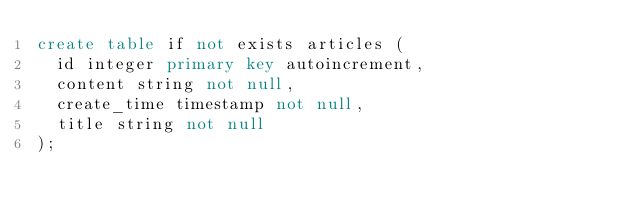Convert code to text. <code><loc_0><loc_0><loc_500><loc_500><_SQL_>create table if not exists articles (
  id integer primary key autoincrement,
  content string not null,
  create_time timestamp not null,
  title string not null
);
</code> 